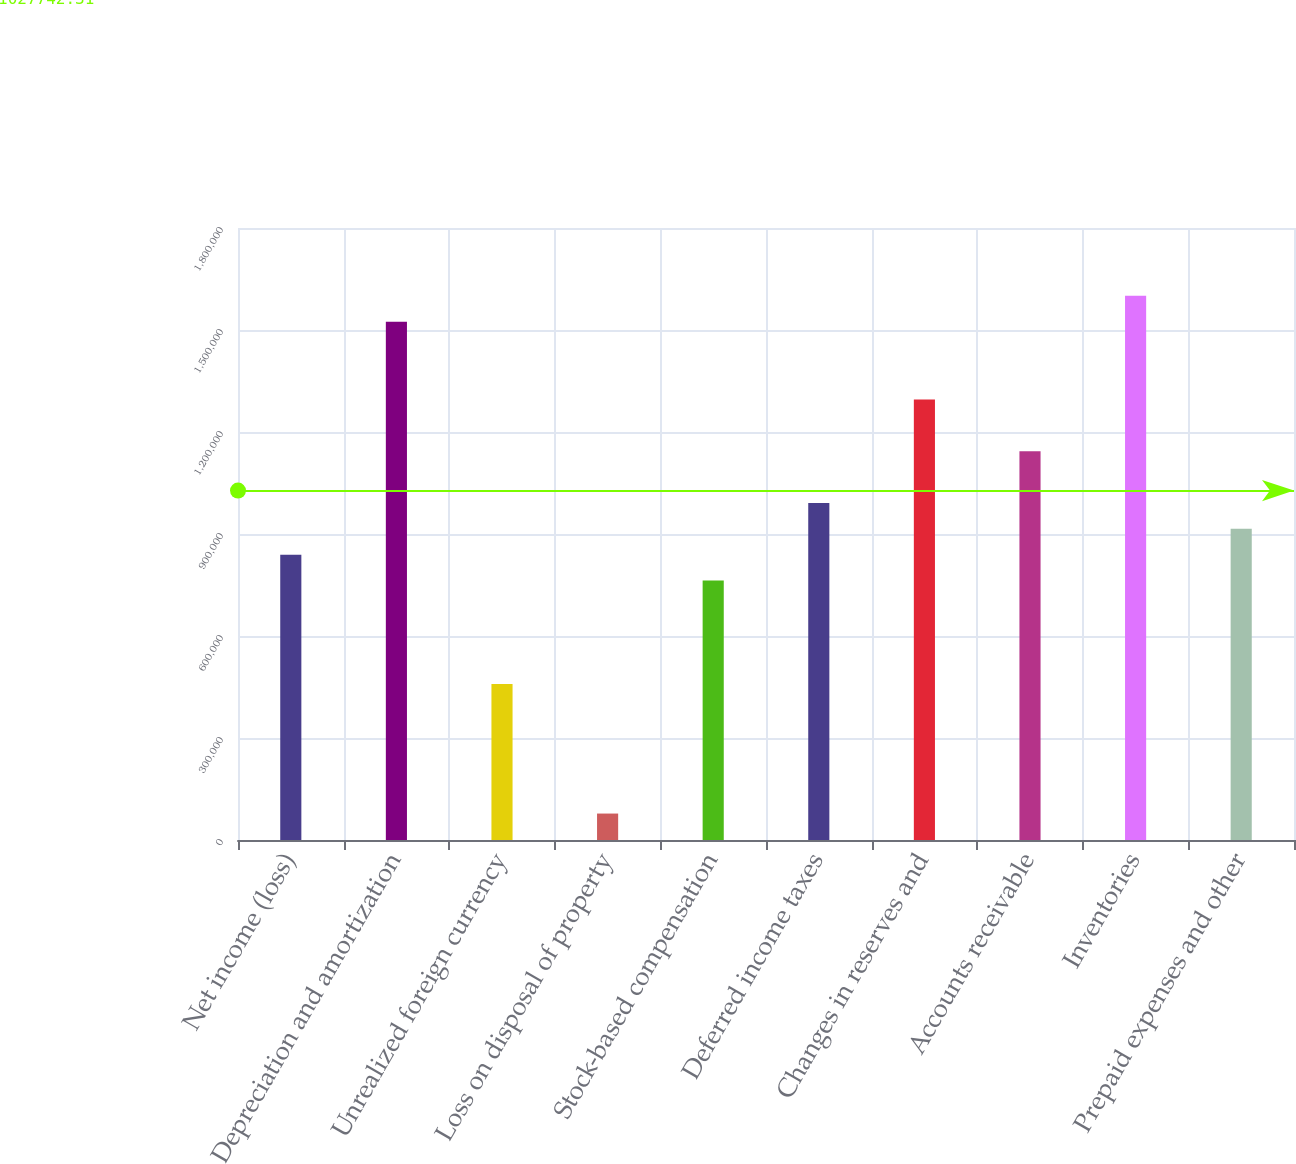<chart> <loc_0><loc_0><loc_500><loc_500><bar_chart><fcel>Net income (loss)<fcel>Depreciation and amortization<fcel>Unrealized foreign currency<fcel>Loss on disposal of property<fcel>Stock-based compensation<fcel>Deferred income taxes<fcel>Changes in reserves and<fcel>Accounts receivable<fcel>Inventories<fcel>Prepaid expenses and other<nl><fcel>839135<fcel>1.52435e+06<fcel>458459<fcel>77783.2<fcel>763000<fcel>991406<fcel>1.29595e+06<fcel>1.14368e+06<fcel>1.60049e+06<fcel>915270<nl></chart> 